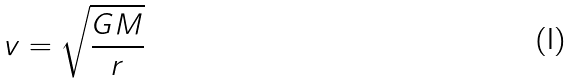<formula> <loc_0><loc_0><loc_500><loc_500>v = \sqrt { \frac { G M } { r } }</formula> 